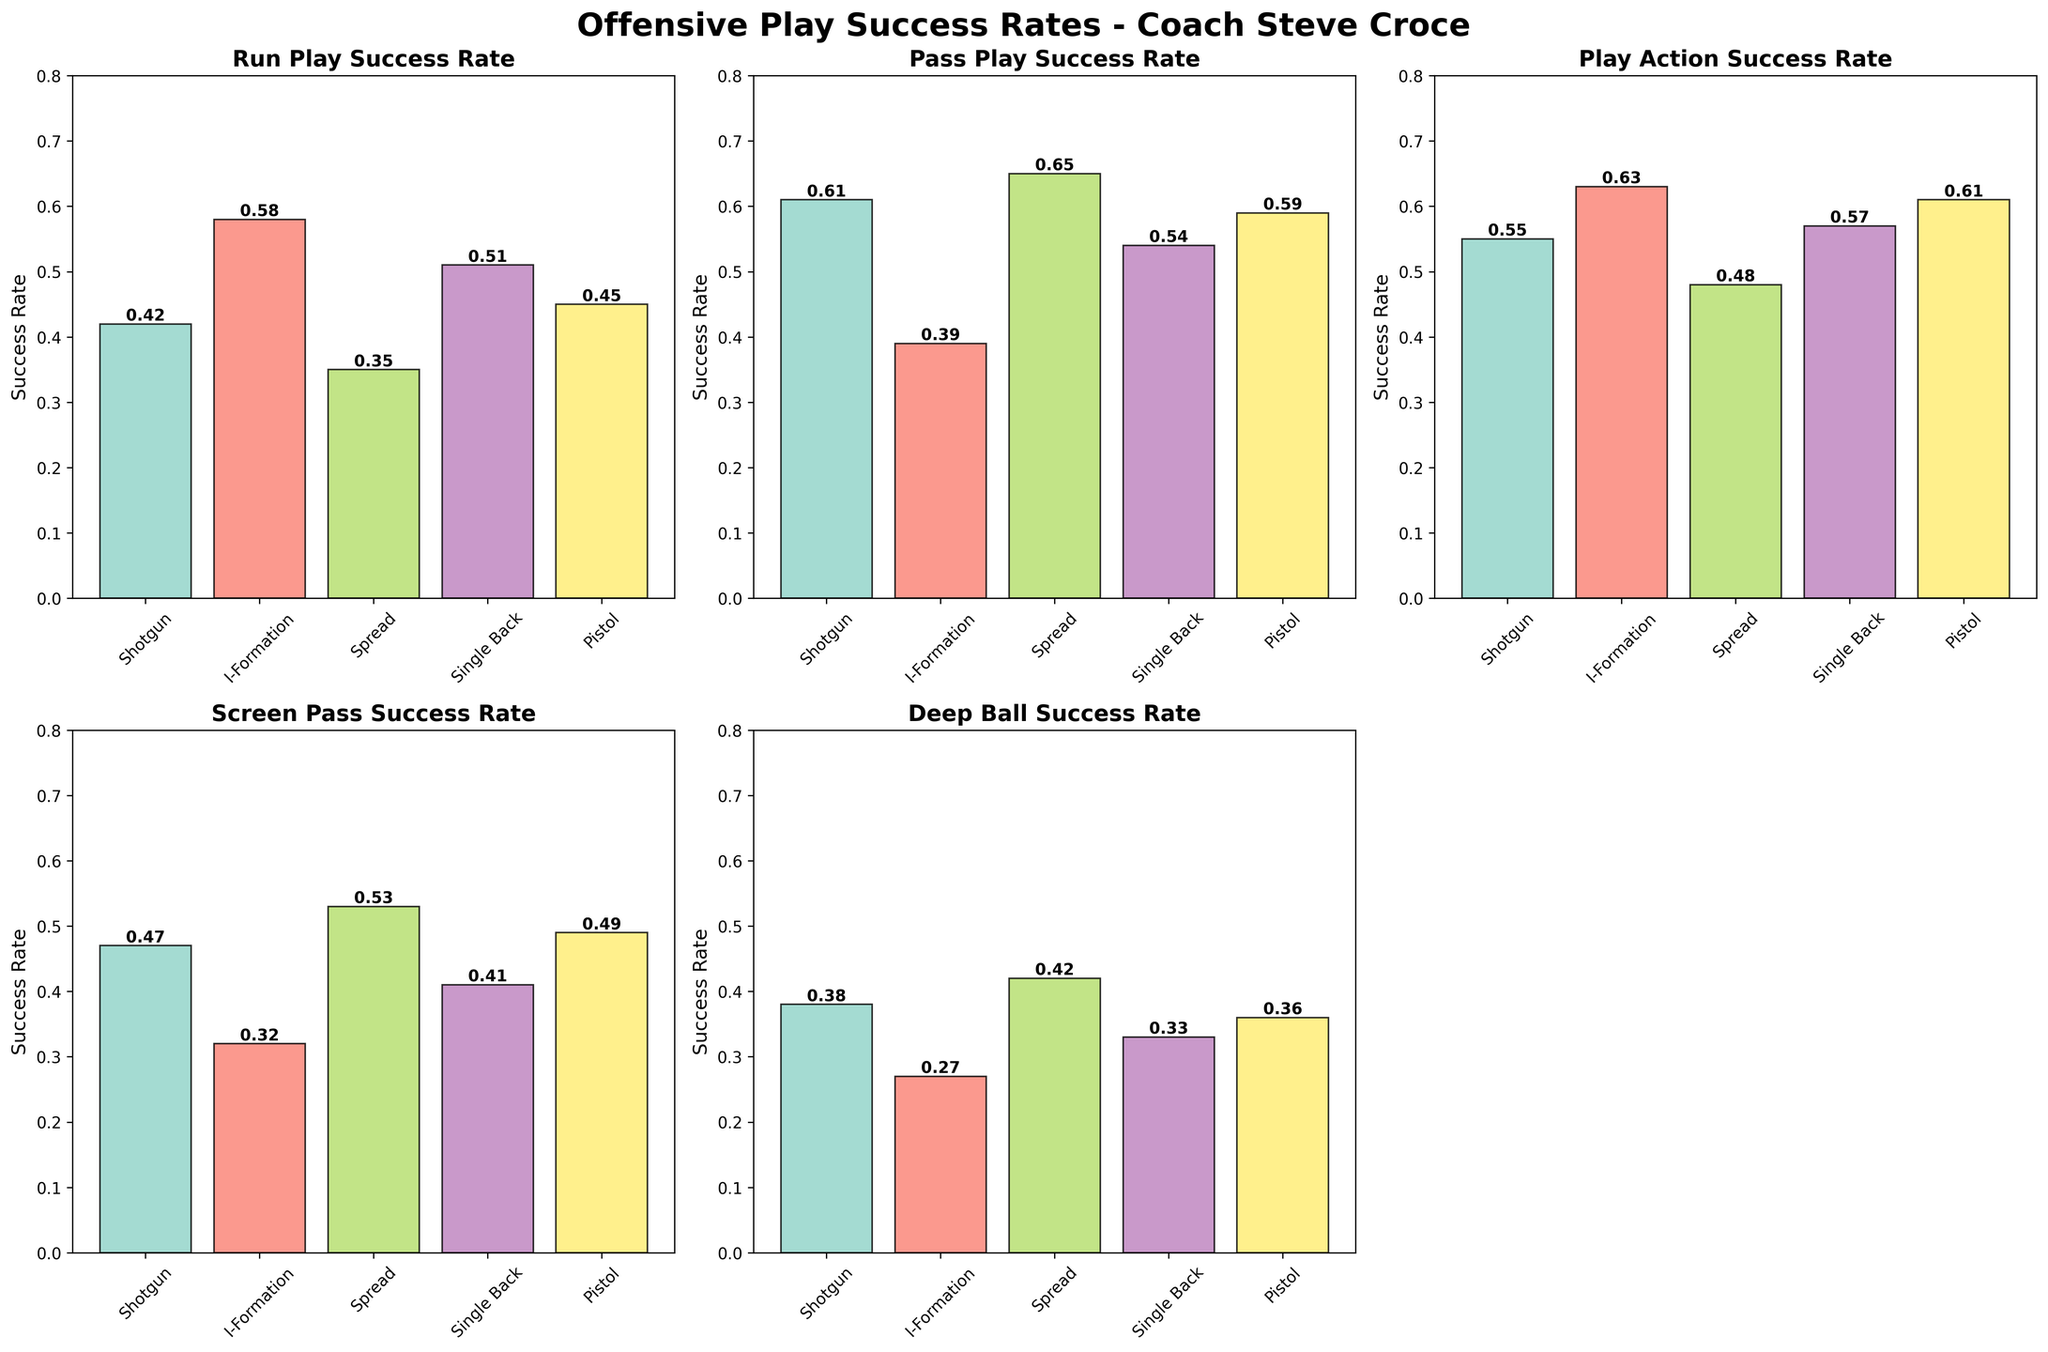What is the title of the figure? The title is usually found at the top of the figure and summarizes what the figure is about.
Answer: Offensive Play Success Rates - Coach Steve Croce Which formation has the highest Run Play Success Rate? Look at the bar heights in the subplot titled "Run Play Success Rate" and identify the tallest bar.
Answer: I-Formation What's the average success rate for Play Action Success Rate across all formations? Add the success rates from the "Play Action Success Rate" subplot and divide by the number of formations. (0.55 + 0.63 + 0.48 + 0.57 + 0.61)/5 = 2.84/5 = 0.568
Answer: 0.57 Which formation shows the largest difference between Run Play Success Rate and Pass Play Success Rate? For each formation, subtract the Run Play Success Rate from the Pass Play Success Rate and identify the maximum difference.
Answer: Shotgun (0.61 - 0.42 = 0.19) Which formation has the lowest Screen Pass Success Rate? Look at the bar heights in the subplot titled "Screen Pass Success Rate" and identify the shortest bar.
Answer: I-Formation Is the Pass Play Success Rate for Spread formation higher or lower than the Play Action Success Rate for the same formation? Compare the bars corresponding to "Pass Play Success Rate" and "Play Action Success Rate" for the "Spread" formation.
Answer: Higher Among the given plays, which play has the highest success rate in Pistol formation? Look at the individual subplots for the "Pistol" formation and identify the tallest bar.
Answer: Play Action Success Rate What is the difference between the highest and lowest success rates in the Single Back formation? Identify the highest and lowest values in the Single Back formation and subtract the lowest from the highest (0.57 - 0.33 = 0.24).
Answer: 0.24 Which play formation has a higher success rate, Run Play in Single Back or Pass Play in I-Formation? Compare the height of the "Run Play Success Rate" bar for the Single Back formation with the height of the "Pass Play Success Rate" bar for the I-Formation.
Answer: Single Back How many subplots are displayed in the figure? Count the individual grid plots shown in the figure.
Answer: 5 